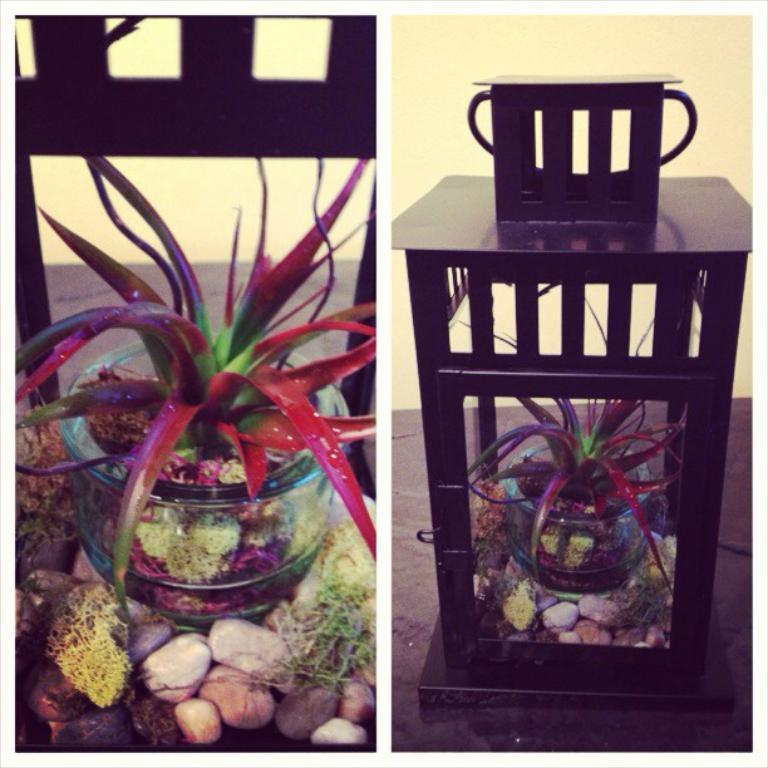What is the main object in the image? There is a glass box in the image. What is inside the glass box? The glass box contains red and green color plants. Are there any other elements in the image besides the glass box? Yes, there are stones in the image. What can be seen on the right side of the image? There is an object inside a table on the right side of the image. Can you tell me how many boys are taking a bath in the image? There are no boys or baths present in the image. What type of request is being made by the person in the image? There is no person making a request in the image; it only features a glass box, plants, stones, and an object inside a table. 